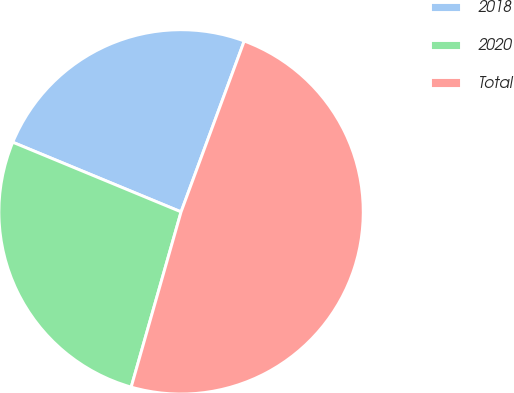Convert chart. <chart><loc_0><loc_0><loc_500><loc_500><pie_chart><fcel>2018<fcel>2020<fcel>Total<nl><fcel>24.39%<fcel>26.83%<fcel>48.78%<nl></chart> 